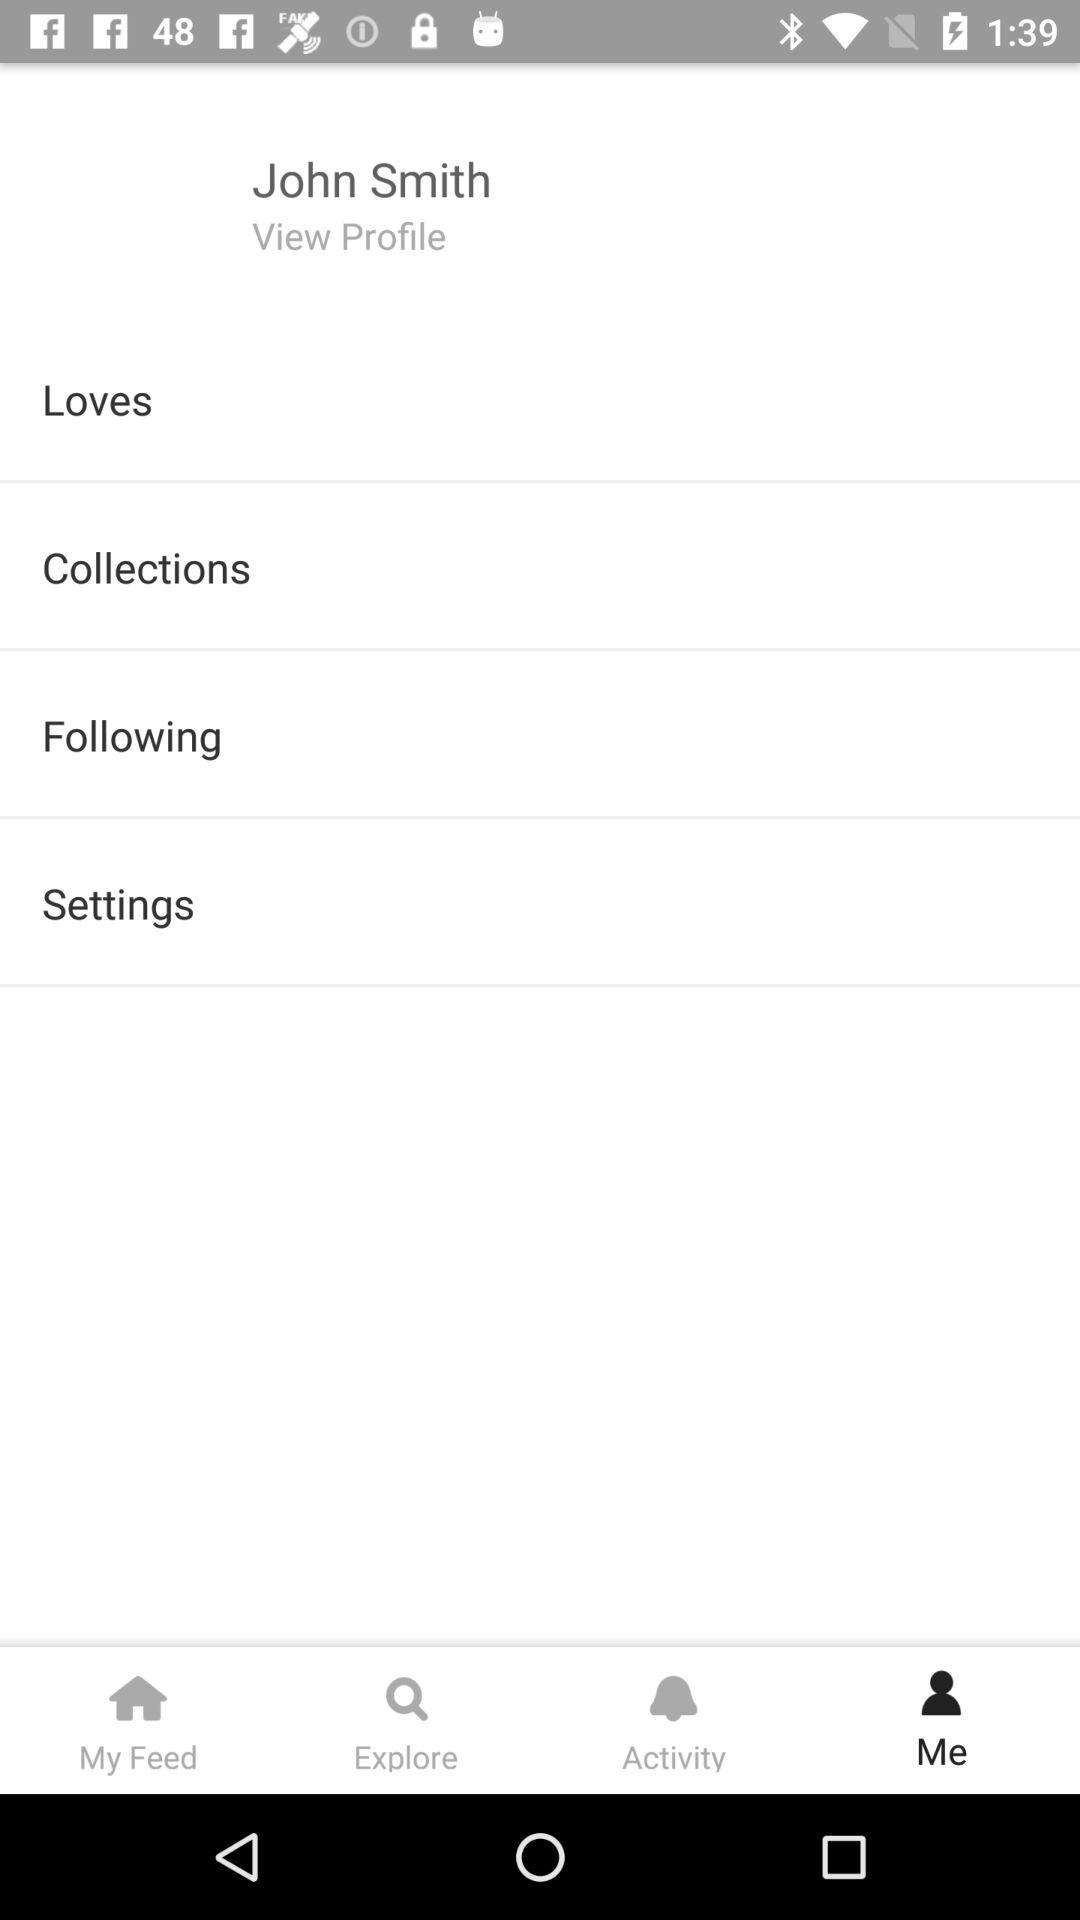Which tab is selected? The selected tab is "Me". 